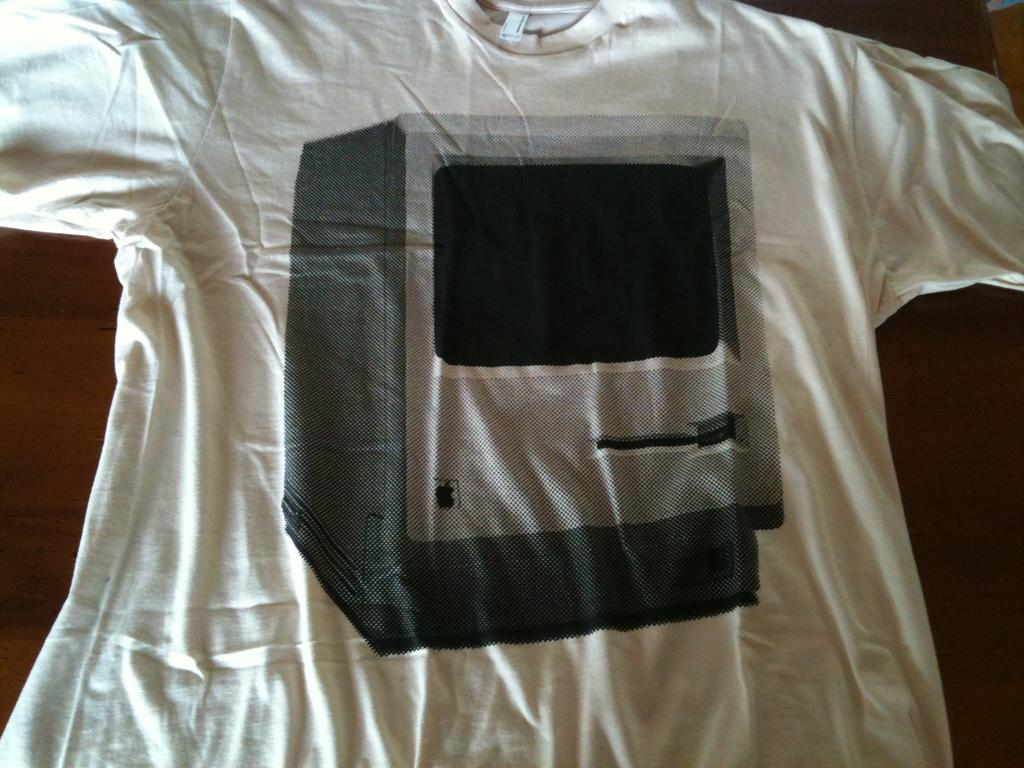What is the color of the surface in the image? The surface in the image is brown. What is placed on the brown surface? There is a white t-shirt on the brown surface. What type of cent can be seen on the white t-shirt in the image? There is no cent or any other design visible on the white t-shirt in the image. Is there a clubhouse in the background of the image? There is no background or any other structures mentioned in the provided facts, so it cannot be determined if there is a clubhouse in the image. 